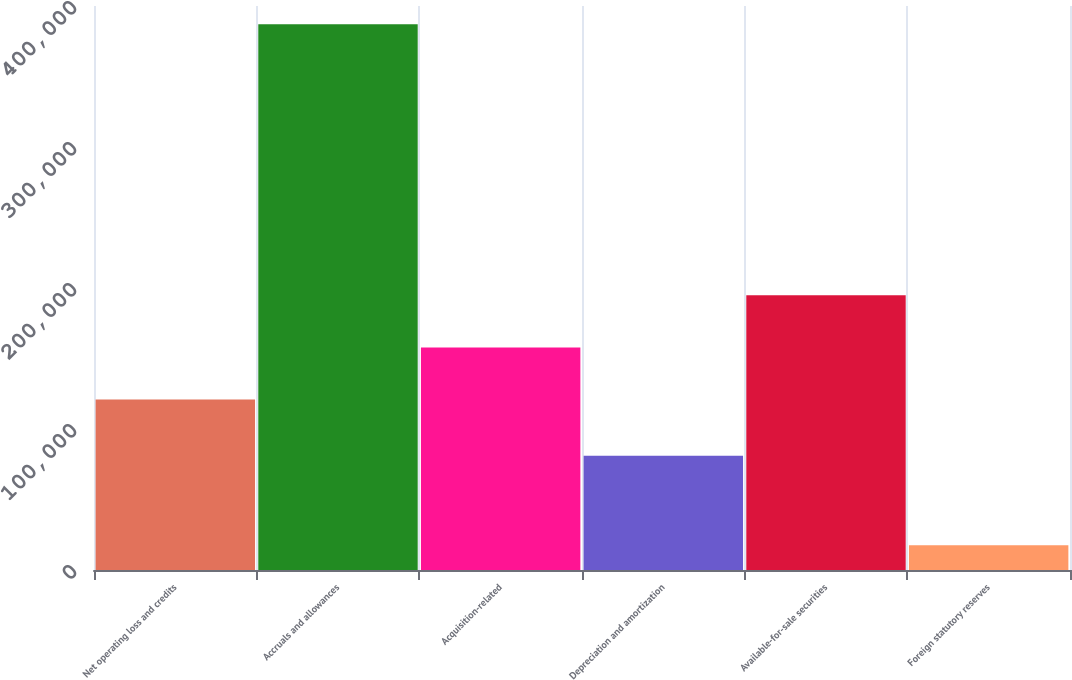Convert chart to OTSL. <chart><loc_0><loc_0><loc_500><loc_500><bar_chart><fcel>Net operating loss and credits<fcel>Accruals and allowances<fcel>Acquisition-related<fcel>Depreciation and amortization<fcel>Available-for-sale securities<fcel>Foreign statutory reserves<nl><fcel>120907<fcel>387140<fcel>157860<fcel>80956<fcel>194812<fcel>17613<nl></chart> 